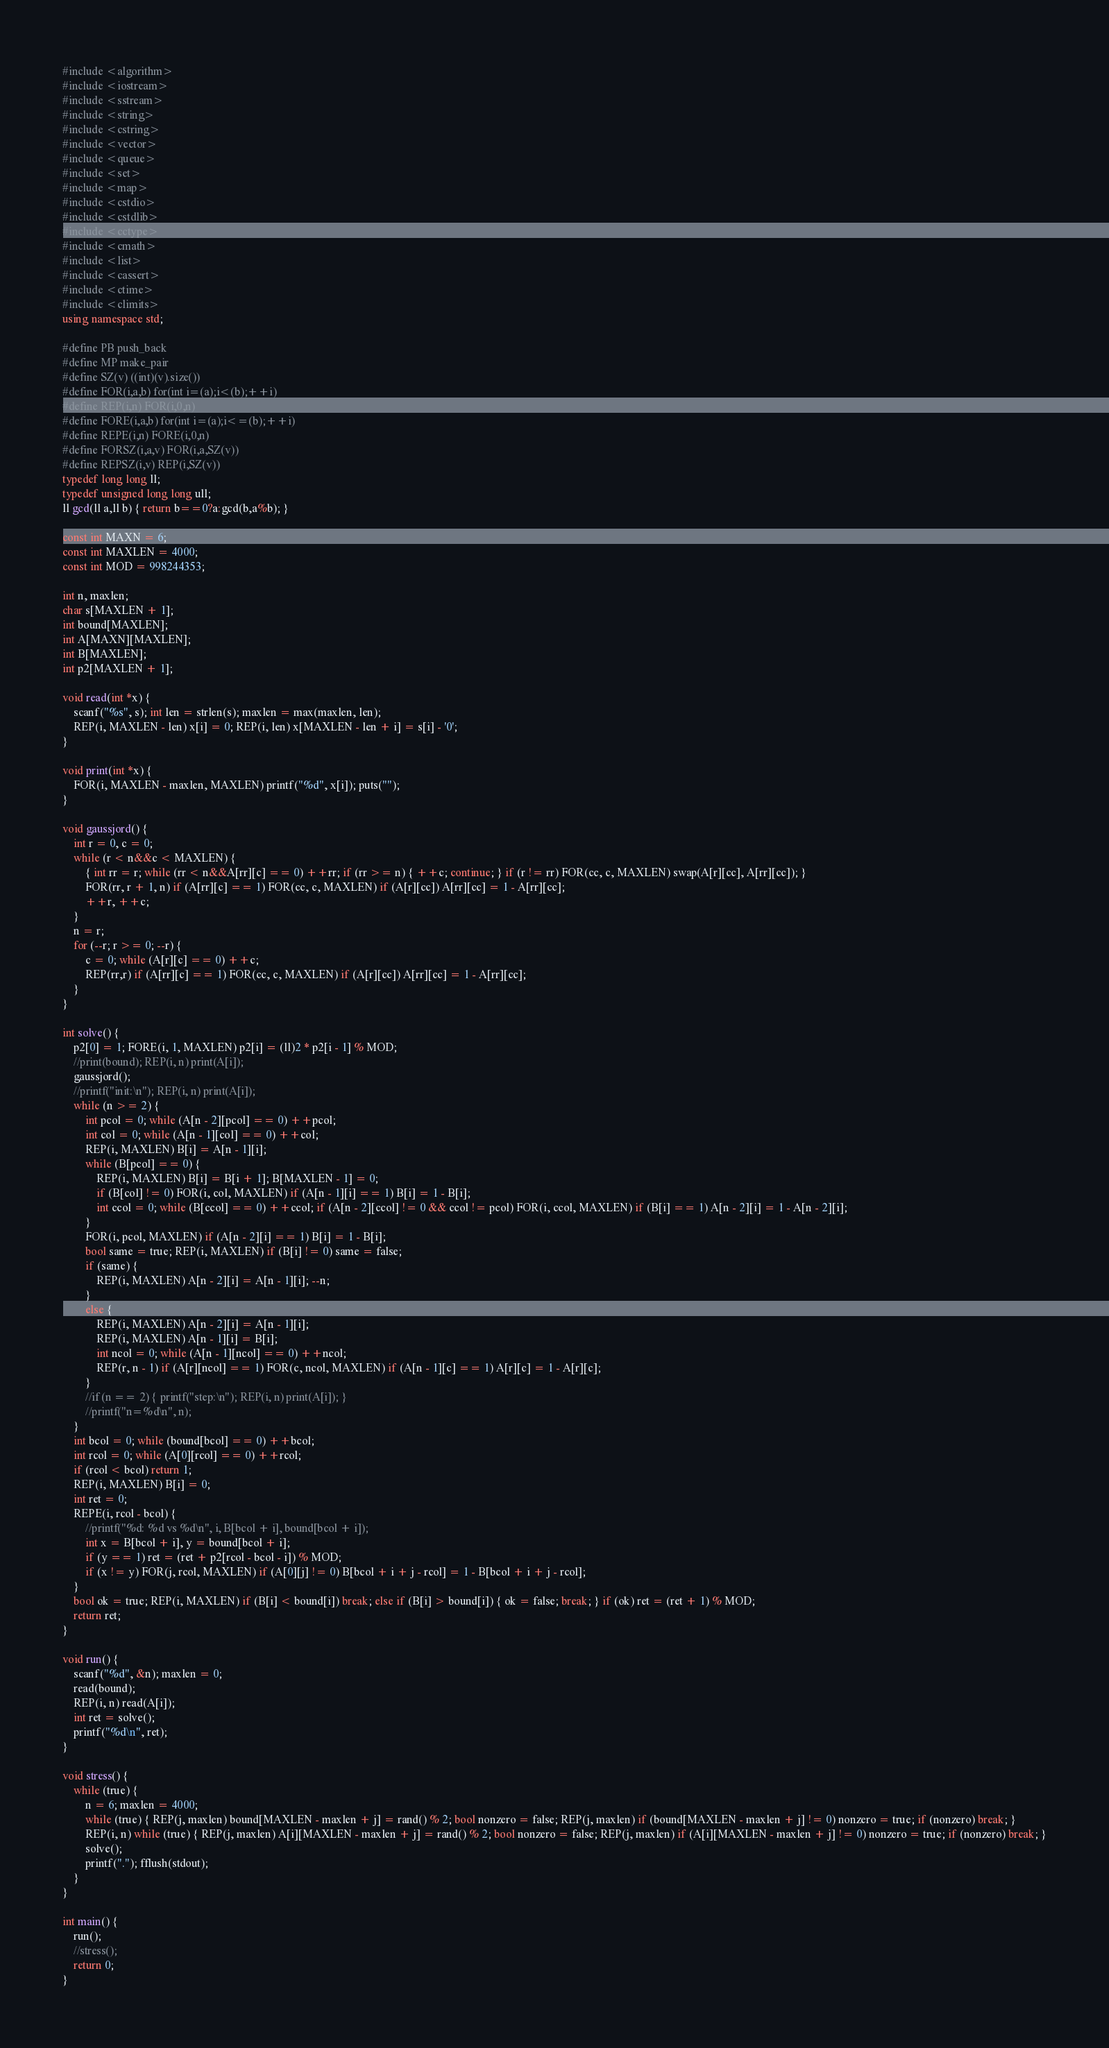Convert code to text. <code><loc_0><loc_0><loc_500><loc_500><_C++_>#include <algorithm>  
#include <iostream>  
#include <sstream>  
#include <string>  
#include <cstring>
#include <vector>  
#include <queue>  
#include <set>  
#include <map>  
#include <cstdio>  
#include <cstdlib>  
#include <cctype>  
#include <cmath>  
#include <list>  
#include <cassert>
#include <ctime>
#include <climits>
using namespace std;  

#define PB push_back  
#define MP make_pair  
#define SZ(v) ((int)(v).size())  
#define FOR(i,a,b) for(int i=(a);i<(b);++i)  
#define REP(i,n) FOR(i,0,n)  
#define FORE(i,a,b) for(int i=(a);i<=(b);++i)  
#define REPE(i,n) FORE(i,0,n)  
#define FORSZ(i,a,v) FOR(i,a,SZ(v))  
#define REPSZ(i,v) REP(i,SZ(v))  
typedef long long ll;
typedef unsigned long long ull;
ll gcd(ll a,ll b) { return b==0?a:gcd(b,a%b); }

const int MAXN = 6;
const int MAXLEN = 4000;
const int MOD = 998244353;

int n, maxlen;
char s[MAXLEN + 1];
int bound[MAXLEN];
int A[MAXN][MAXLEN];
int B[MAXLEN];
int p2[MAXLEN + 1];

void read(int *x) {
	scanf("%s", s); int len = strlen(s); maxlen = max(maxlen, len);
	REP(i, MAXLEN - len) x[i] = 0; REP(i, len) x[MAXLEN - len + i] = s[i] - '0';
}

void print(int *x) {
	FOR(i, MAXLEN - maxlen, MAXLEN) printf("%d", x[i]); puts("");
}

void gaussjord() {
	int r = 0, c = 0;
	while (r < n&&c < MAXLEN) {
		{ int rr = r; while (rr < n&&A[rr][c] == 0) ++rr; if (rr >= n) { ++c; continue; } if (r != rr) FOR(cc, c, MAXLEN) swap(A[r][cc], A[rr][cc]); }
		FOR(rr, r + 1, n) if (A[rr][c] == 1) FOR(cc, c, MAXLEN) if (A[r][cc]) A[rr][cc] = 1 - A[rr][cc];
		++r, ++c;
	}
	n = r;
	for (--r; r >= 0; --r) {
		c = 0; while (A[r][c] == 0) ++c;
		REP(rr,r) if (A[rr][c] == 1) FOR(cc, c, MAXLEN) if (A[r][cc]) A[rr][cc] = 1 - A[rr][cc];
	}
}

int solve() {
	p2[0] = 1; FORE(i, 1, MAXLEN) p2[i] = (ll)2 * p2[i - 1] % MOD;
	//print(bound); REP(i, n) print(A[i]);
	gaussjord();
	//printf("init:\n"); REP(i, n) print(A[i]);
	while (n >= 2) {
		int pcol = 0; while (A[n - 2][pcol] == 0) ++pcol;
		int col = 0; while (A[n - 1][col] == 0) ++col;
		REP(i, MAXLEN) B[i] = A[n - 1][i];
		while (B[pcol] == 0) {
			REP(i, MAXLEN) B[i] = B[i + 1]; B[MAXLEN - 1] = 0;
			if (B[col] != 0) FOR(i, col, MAXLEN) if (A[n - 1][i] == 1) B[i] = 1 - B[i];
			int ccol = 0; while (B[ccol] == 0) ++ccol; if (A[n - 2][ccol] != 0 && ccol != pcol) FOR(i, ccol, MAXLEN) if (B[i] == 1) A[n - 2][i] = 1 - A[n - 2][i];
		}
		FOR(i, pcol, MAXLEN) if (A[n - 2][i] == 1) B[i] = 1 - B[i];
		bool same = true; REP(i, MAXLEN) if (B[i] != 0) same = false;
		if (same) {
			REP(i, MAXLEN) A[n - 2][i] = A[n - 1][i]; --n;
		}
		else {
			REP(i, MAXLEN) A[n - 2][i] = A[n - 1][i];
			REP(i, MAXLEN) A[n - 1][i] = B[i];
			int ncol = 0; while (A[n - 1][ncol] == 0) ++ncol;
			REP(r, n - 1) if (A[r][ncol] == 1) FOR(c, ncol, MAXLEN) if (A[n - 1][c] == 1) A[r][c] = 1 - A[r][c];
		}
		//if (n == 2) { printf("step:\n"); REP(i, n) print(A[i]); }
		//printf("n=%d\n", n);
	}
	int bcol = 0; while (bound[bcol] == 0) ++bcol;
	int rcol = 0; while (A[0][rcol] == 0) ++rcol;
	if (rcol < bcol) return 1;
	REP(i, MAXLEN) B[i] = 0;
	int ret = 0;
	REPE(i, rcol - bcol) {
		//printf("%d: %d vs %d\n", i, B[bcol + i], bound[bcol + i]);
		int x = B[bcol + i], y = bound[bcol + i];
		if (y == 1) ret = (ret + p2[rcol - bcol - i]) % MOD;
		if (x != y) FOR(j, rcol, MAXLEN) if (A[0][j] != 0) B[bcol + i + j - rcol] = 1 - B[bcol + i + j - rcol];
	}
	bool ok = true; REP(i, MAXLEN) if (B[i] < bound[i]) break; else if (B[i] > bound[i]) { ok = false; break; } if (ok) ret = (ret + 1) % MOD;
	return ret;
}

void run() {
	scanf("%d", &n); maxlen = 0;
	read(bound);
	REP(i, n) read(A[i]);
	int ret = solve();
	printf("%d\n", ret);
}

void stress() {
	while (true) {
		n = 6; maxlen = 4000;
		while (true) { REP(j, maxlen) bound[MAXLEN - maxlen + j] = rand() % 2; bool nonzero = false; REP(j, maxlen) if (bound[MAXLEN - maxlen + j] != 0) nonzero = true; if (nonzero) break; }
		REP(i, n) while (true) { REP(j, maxlen) A[i][MAXLEN - maxlen + j] = rand() % 2; bool nonzero = false; REP(j, maxlen) if (A[i][MAXLEN - maxlen + j] != 0) nonzero = true; if (nonzero) break; }
		solve();
		printf("."); fflush(stdout);
	}
}

int main() {
	run();
	//stress();
	return 0;
}
</code> 